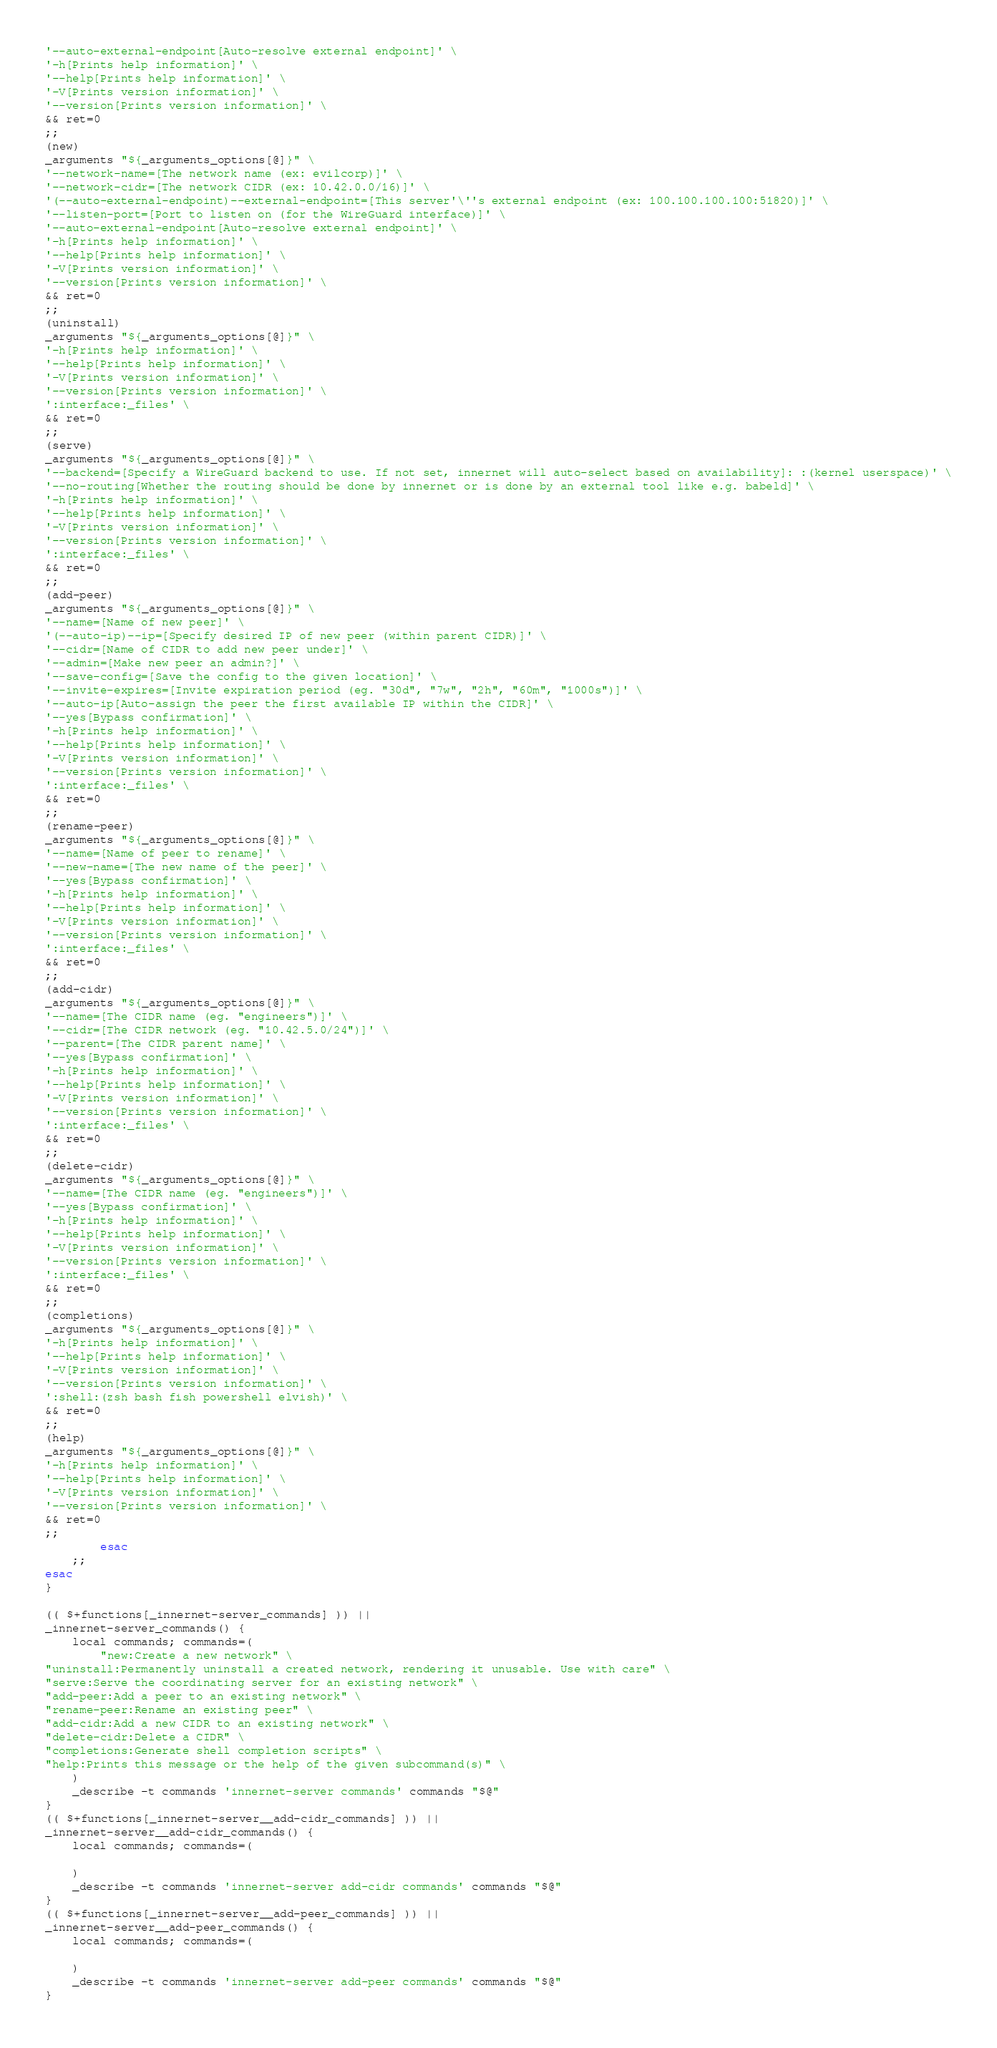Convert code to text. <code><loc_0><loc_0><loc_500><loc_500><_Bash_>'--auto-external-endpoint[Auto-resolve external endpoint]' \
'-h[Prints help information]' \
'--help[Prints help information]' \
'-V[Prints version information]' \
'--version[Prints version information]' \
&& ret=0
;;
(new)
_arguments "${_arguments_options[@]}" \
'--network-name=[The network name (ex: evilcorp)]' \
'--network-cidr=[The network CIDR (ex: 10.42.0.0/16)]' \
'(--auto-external-endpoint)--external-endpoint=[This server'\''s external endpoint (ex: 100.100.100.100:51820)]' \
'--listen-port=[Port to listen on (for the WireGuard interface)]' \
'--auto-external-endpoint[Auto-resolve external endpoint]' \
'-h[Prints help information]' \
'--help[Prints help information]' \
'-V[Prints version information]' \
'--version[Prints version information]' \
&& ret=0
;;
(uninstall)
_arguments "${_arguments_options[@]}" \
'-h[Prints help information]' \
'--help[Prints help information]' \
'-V[Prints version information]' \
'--version[Prints version information]' \
':interface:_files' \
&& ret=0
;;
(serve)
_arguments "${_arguments_options[@]}" \
'--backend=[Specify a WireGuard backend to use. If not set, innernet will auto-select based on availability]: :(kernel userspace)' \
'--no-routing[Whether the routing should be done by innernet or is done by an external tool like e.g. babeld]' \
'-h[Prints help information]' \
'--help[Prints help information]' \
'-V[Prints version information]' \
'--version[Prints version information]' \
':interface:_files' \
&& ret=0
;;
(add-peer)
_arguments "${_arguments_options[@]}" \
'--name=[Name of new peer]' \
'(--auto-ip)--ip=[Specify desired IP of new peer (within parent CIDR)]' \
'--cidr=[Name of CIDR to add new peer under]' \
'--admin=[Make new peer an admin?]' \
'--save-config=[Save the config to the given location]' \
'--invite-expires=[Invite expiration period (eg. "30d", "7w", "2h", "60m", "1000s")]' \
'--auto-ip[Auto-assign the peer the first available IP within the CIDR]' \
'--yes[Bypass confirmation]' \
'-h[Prints help information]' \
'--help[Prints help information]' \
'-V[Prints version information]' \
'--version[Prints version information]' \
':interface:_files' \
&& ret=0
;;
(rename-peer)
_arguments "${_arguments_options[@]}" \
'--name=[Name of peer to rename]' \
'--new-name=[The new name of the peer]' \
'--yes[Bypass confirmation]' \
'-h[Prints help information]' \
'--help[Prints help information]' \
'-V[Prints version information]' \
'--version[Prints version information]' \
':interface:_files' \
&& ret=0
;;
(add-cidr)
_arguments "${_arguments_options[@]}" \
'--name=[The CIDR name (eg. "engineers")]' \
'--cidr=[The CIDR network (eg. "10.42.5.0/24")]' \
'--parent=[The CIDR parent name]' \
'--yes[Bypass confirmation]' \
'-h[Prints help information]' \
'--help[Prints help information]' \
'-V[Prints version information]' \
'--version[Prints version information]' \
':interface:_files' \
&& ret=0
;;
(delete-cidr)
_arguments "${_arguments_options[@]}" \
'--name=[The CIDR name (eg. "engineers")]' \
'--yes[Bypass confirmation]' \
'-h[Prints help information]' \
'--help[Prints help information]' \
'-V[Prints version information]' \
'--version[Prints version information]' \
':interface:_files' \
&& ret=0
;;
(completions)
_arguments "${_arguments_options[@]}" \
'-h[Prints help information]' \
'--help[Prints help information]' \
'-V[Prints version information]' \
'--version[Prints version information]' \
':shell:(zsh bash fish powershell elvish)' \
&& ret=0
;;
(help)
_arguments "${_arguments_options[@]}" \
'-h[Prints help information]' \
'--help[Prints help information]' \
'-V[Prints version information]' \
'--version[Prints version information]' \
&& ret=0
;;
        esac
    ;;
esac
}

(( $+functions[_innernet-server_commands] )) ||
_innernet-server_commands() {
    local commands; commands=(
        "new:Create a new network" \
"uninstall:Permanently uninstall a created network, rendering it unusable. Use with care" \
"serve:Serve the coordinating server for an existing network" \
"add-peer:Add a peer to an existing network" \
"rename-peer:Rename an existing peer" \
"add-cidr:Add a new CIDR to an existing network" \
"delete-cidr:Delete a CIDR" \
"completions:Generate shell completion scripts" \
"help:Prints this message or the help of the given subcommand(s)" \
    )
    _describe -t commands 'innernet-server commands' commands "$@"
}
(( $+functions[_innernet-server__add-cidr_commands] )) ||
_innernet-server__add-cidr_commands() {
    local commands; commands=(
        
    )
    _describe -t commands 'innernet-server add-cidr commands' commands "$@"
}
(( $+functions[_innernet-server__add-peer_commands] )) ||
_innernet-server__add-peer_commands() {
    local commands; commands=(
        
    )
    _describe -t commands 'innernet-server add-peer commands' commands "$@"
}</code> 